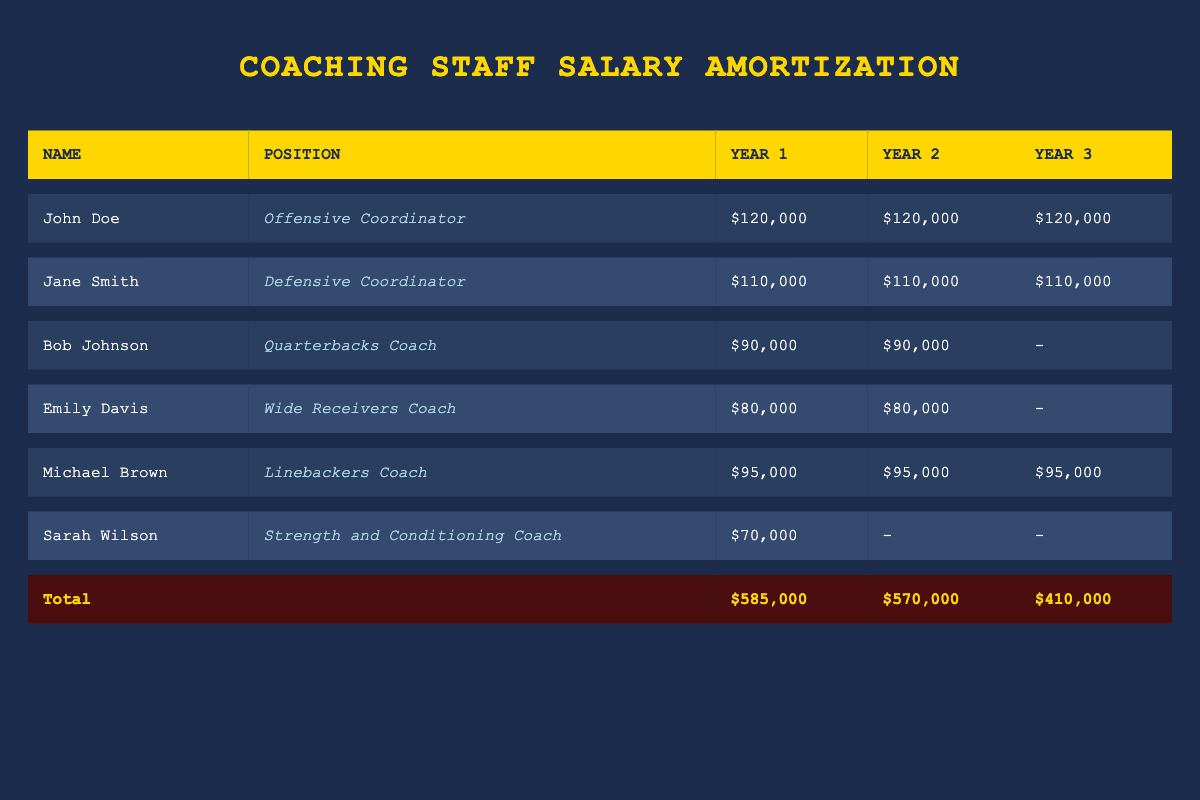What is the total salary allocated to John Doe in Year 1? According to the table, John Doe's annual salary is $120,000 for Year 1. Each coach's allocated salary is listed in their respective rows, and for John Doe, it is clearly stated.
Answer: 120,000 How much does Sarah Wilson earn in Year 2? In the table, under the row for Sarah Wilson, it shows a dash (-) for Year 2, indicating that she is not allocated any salary in that year, as her contract lasts only for Year 1.
Answer: 0 What is the total salary for Year 3? The aggregated total salary for Year 3 is displayed at the bottom of the table, which states $410,000. This is the sum of all allocated salaries for the coaches active in that year.
Answer: 410,000 Is Bob Johnson's salary the same in Year 1 and Year 2? In the table, Bob Johnson's salary is listed as $90,000 for both Year 1 and Year 2, confirming that his salary has not changed in those two years.
Answer: Yes What is the average salary of the coaching staff in Year 1? To find the average salary, first sum the salaries for Year 1: 120,000 + 110,000 + 90,000 + 80,000 + 95,000 + 70,000 = 585,000. Since there are 6 coaches, divide the total by 6: 585,000 / 6 = 97,500.
Answer: 97,500 How much more is allocated in total to coaching salaries in Year 1 compared to Year 3? The total for Year 1 is $585,000 and for Year 3 it is $410,000. To find the difference, subtract Year 3 from Year 1: 585,000 - 410,000 = 175,000.
Answer: 175,000 Which coach has the highest salary in Year 2? Referring to the Year 2 column, John Doe and Jane Smith both receive $120,000 and $110,000 respectively, while the others receive less. Therefore, John Doe has the highest salary.
Answer: John Doe How many coaches' salaries are active in Year 3? In Year 3, the allocated salaries are listed as $120,000 for John Doe, $110,000 for Jane Smith, and $95,000 for Michael Brown. Bob Johnson, Emily Davis, and Sarah Wilson have no salaries listed, so there are a total of 3 active coaches.
Answer: 3 What is Michael Brown's total salary over the three years? Michael Brown's salary is $95,000 for Year 1, $95,000 for Year 2, and $95,000 for Year 3. To find the total, sum these amounts: 95,000 + 95,000 + 95,000 = 285,000.
Answer: 285,000 What positions are vacant for Year 2 based on the salary allocations? Looking at the Year 2 allocations, Sarah Wilson has no salary assigned since her contract only lasts for Year 1. Thus, her position is vacant for Year 2.
Answer: Yes 